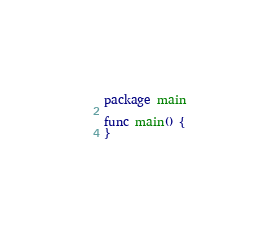<code> <loc_0><loc_0><loc_500><loc_500><_Go_>package main

func main() {
}
</code> 